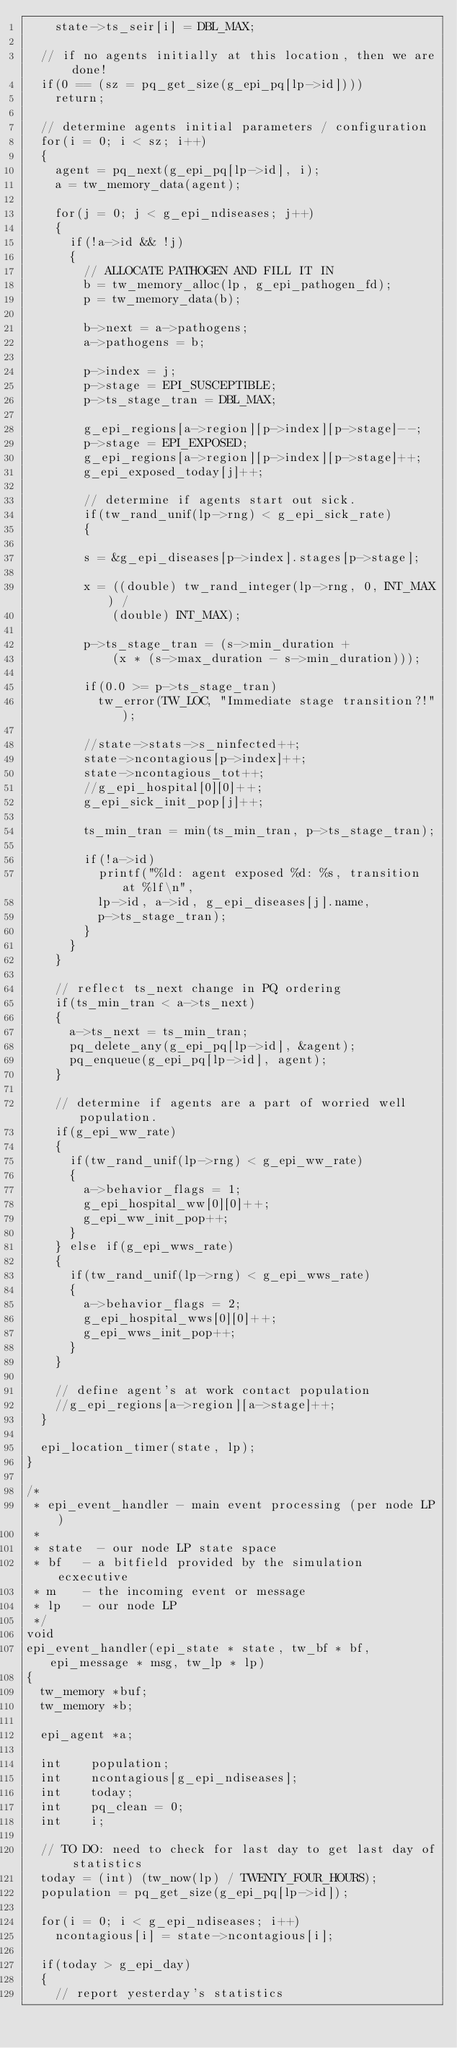Convert code to text. <code><loc_0><loc_0><loc_500><loc_500><_C_>		state->ts_seir[i] = DBL_MAX;

	// if no agents initially at this location, then we are done!
	if(0 == (sz = pq_get_size(g_epi_pq[lp->id])))
		return;

	// determine agents initial parameters / configuration
	for(i = 0; i < sz; i++)
	{
		agent = pq_next(g_epi_pq[lp->id], i);
		a = tw_memory_data(agent);

		for(j = 0; j < g_epi_ndiseases; j++)
		{
			if(!a->id && !j)
			{
				// ALLOCATE PATHOGEN AND FILL IT IN
				b = tw_memory_alloc(lp, g_epi_pathogen_fd);
				p = tw_memory_data(b);

				b->next = a->pathogens;
				a->pathogens = b;

				p->index = j;
				p->stage = EPI_SUSCEPTIBLE;
				p->ts_stage_tran = DBL_MAX;

				g_epi_regions[a->region][p->index][p->stage]--;
				p->stage = EPI_EXPOSED;
				g_epi_regions[a->region][p->index][p->stage]++;
				g_epi_exposed_today[j]++;
	
				// determine if agents start out sick.
				if(tw_rand_unif(lp->rng) < g_epi_sick_rate)
				{

				s = &g_epi_diseases[p->index].stages[p->stage];

				x = ((double) tw_rand_integer(lp->rng, 0, INT_MAX) / 
						(double) INT_MAX);

				p->ts_stage_tran = (s->min_duration + 
						(x * (s->max_duration - s->min_duration)));

				if(0.0 >= p->ts_stage_tran)
					tw_error(TW_LOC, "Immediate stage transition?!");

				//state->stats->s_ninfected++;
				state->ncontagious[p->index]++;
				state->ncontagious_tot++;
				//g_epi_hospital[0][0]++;
				g_epi_sick_init_pop[j]++;

				ts_min_tran = min(ts_min_tran, p->ts_stage_tran);

				if(!a->id)
					printf("%ld: agent exposed %d: %s, transition at %lf\n", 
					lp->id, a->id, g_epi_diseases[j].name, 
					p->ts_stage_tran);
				}
			}
		}

		// reflect ts_next change in PQ ordering
		if(ts_min_tran < a->ts_next)
		{
			a->ts_next = ts_min_tran;
			pq_delete_any(g_epi_pq[lp->id], &agent);
			pq_enqueue(g_epi_pq[lp->id], agent);
		}

		// determine if agents are a part of worried well population.
		if(g_epi_ww_rate)
		{
			if(tw_rand_unif(lp->rng) < g_epi_ww_rate)
			{
				a->behavior_flags = 1;
				g_epi_hospital_ww[0][0]++;
				g_epi_ww_init_pop++;
			}
		} else if(g_epi_wws_rate)
		{
			if(tw_rand_unif(lp->rng) < g_epi_wws_rate)
			{
				a->behavior_flags = 2;
				g_epi_hospital_wws[0][0]++;
				g_epi_wws_init_pop++;
			}
		}

		// define agent's at work contact population
		//g_epi_regions[a->region][a->stage]++;
	}

	epi_location_timer(state, lp);
}

/*
 * epi_event_handler - main event processing (per node LP)
 * 
 * state	- our node LP state space
 * bf		- a bitfield provided by the simulation ecxecutive
 * m		- the incoming event or message
 * lp		- our node LP
 */
void
epi_event_handler(epi_state * state, tw_bf * bf, epi_message * msg, tw_lp * lp)
{
	tw_memory	*buf;
	tw_memory	*b;

	epi_agent	*a;

	int		 population;
	int		 ncontagious[g_epi_ndiseases];
	int		 today;
	int		 pq_clean = 0;
	int		 i;

	// TO DO: need to check for last day to get last day of statistics
	today = (int) (tw_now(lp) / TWENTY_FOUR_HOURS);
	population = pq_get_size(g_epi_pq[lp->id]);

	for(i = 0; i < g_epi_ndiseases; i++)
		ncontagious[i] = state->ncontagious[i];

	if(today > g_epi_day)
	{
		// report yesterday's statistics</code> 